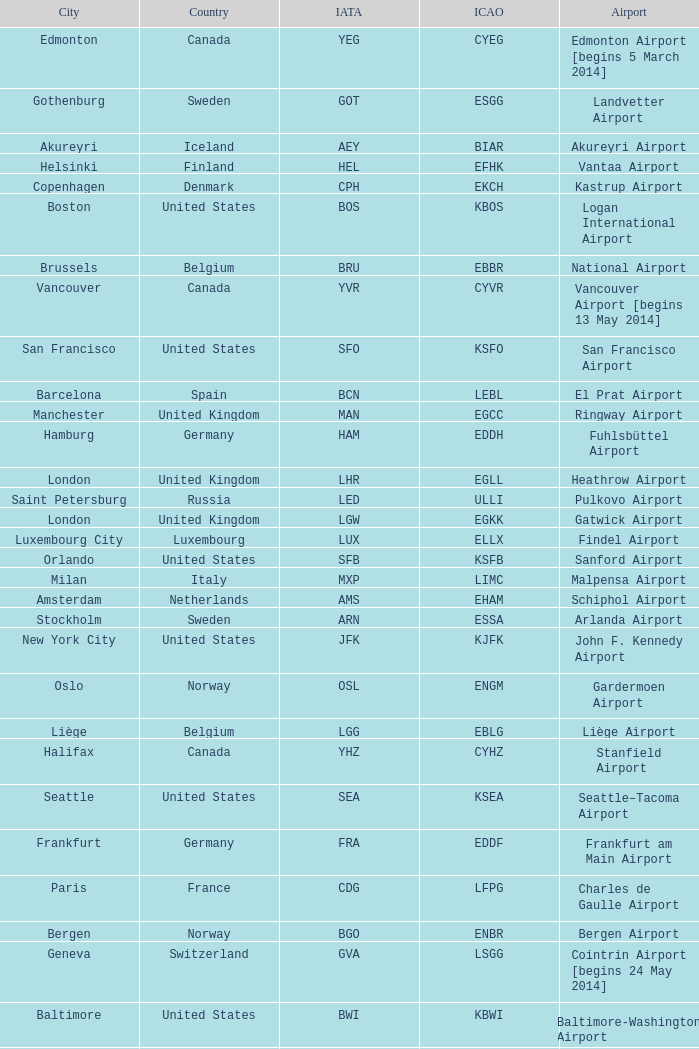What is the IATA OF Akureyri? AEY. 